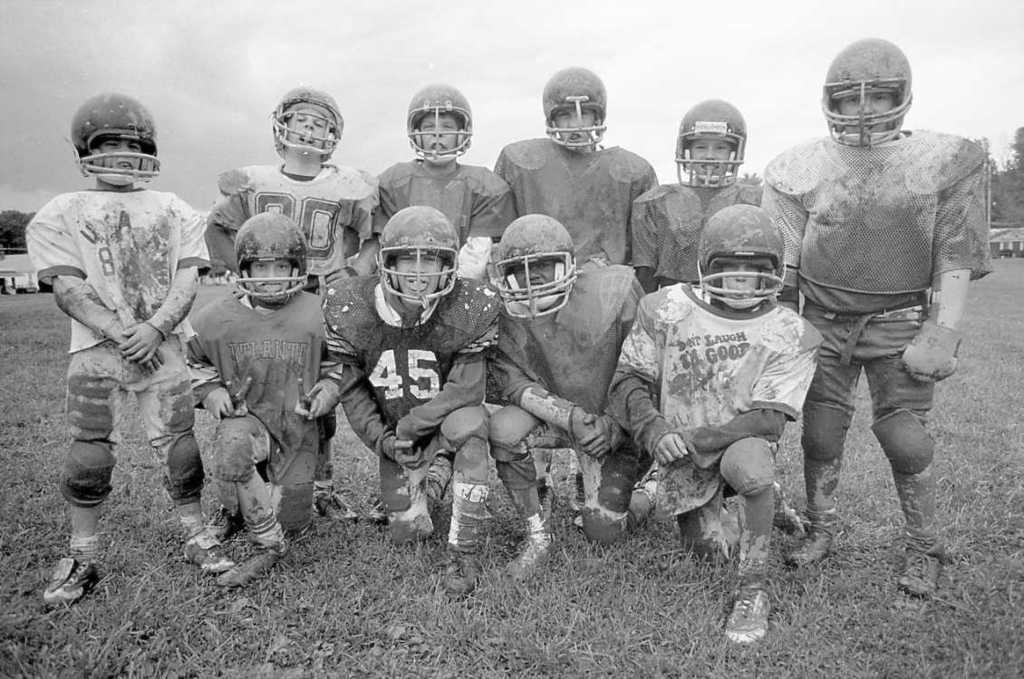In one or two sentences, can you explain what this image depicts? In the picture we can see group of people wearing sports dress, helmets, some are standing and some are crouching down and in the background of the picture there are some trees, cloudy sky. 